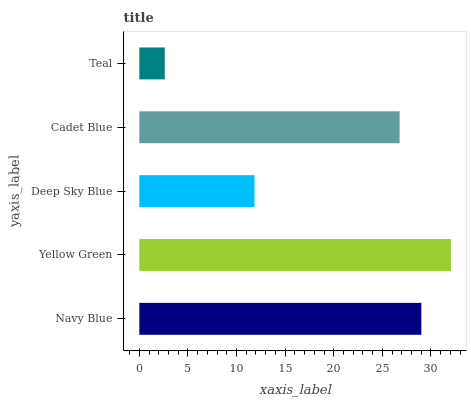Is Teal the minimum?
Answer yes or no. Yes. Is Yellow Green the maximum?
Answer yes or no. Yes. Is Deep Sky Blue the minimum?
Answer yes or no. No. Is Deep Sky Blue the maximum?
Answer yes or no. No. Is Yellow Green greater than Deep Sky Blue?
Answer yes or no. Yes. Is Deep Sky Blue less than Yellow Green?
Answer yes or no. Yes. Is Deep Sky Blue greater than Yellow Green?
Answer yes or no. No. Is Yellow Green less than Deep Sky Blue?
Answer yes or no. No. Is Cadet Blue the high median?
Answer yes or no. Yes. Is Cadet Blue the low median?
Answer yes or no. Yes. Is Teal the high median?
Answer yes or no. No. Is Deep Sky Blue the low median?
Answer yes or no. No. 